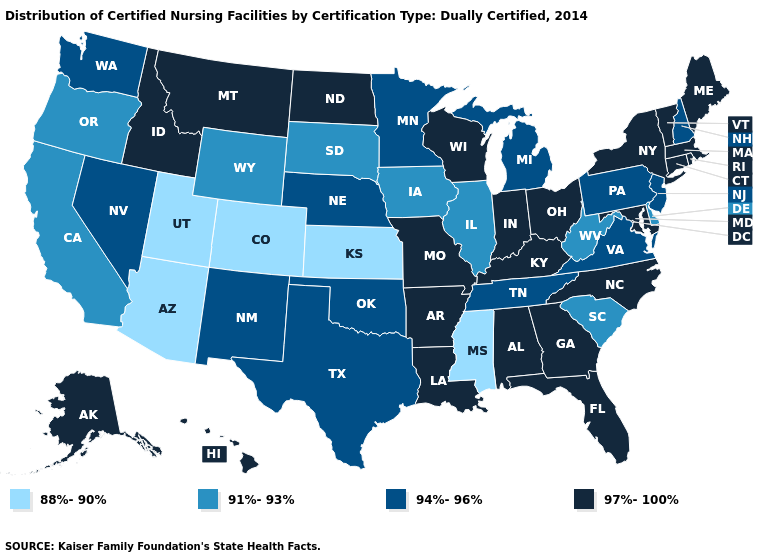Among the states that border New Mexico , which have the highest value?
Answer briefly. Oklahoma, Texas. Name the states that have a value in the range 94%-96%?
Be succinct. Michigan, Minnesota, Nebraska, Nevada, New Hampshire, New Jersey, New Mexico, Oklahoma, Pennsylvania, Tennessee, Texas, Virginia, Washington. Does Illinois have a lower value than South Dakota?
Write a very short answer. No. What is the highest value in the USA?
Be succinct. 97%-100%. Among the states that border Texas , which have the lowest value?
Answer briefly. New Mexico, Oklahoma. Does Louisiana have the highest value in the South?
Short answer required. Yes. Among the states that border Delaware , does Pennsylvania have the lowest value?
Concise answer only. Yes. Among the states that border Mississippi , which have the lowest value?
Write a very short answer. Tennessee. Does the first symbol in the legend represent the smallest category?
Be succinct. Yes. Does Maine have the lowest value in the Northeast?
Concise answer only. No. Name the states that have a value in the range 91%-93%?
Short answer required. California, Delaware, Illinois, Iowa, Oregon, South Carolina, South Dakota, West Virginia, Wyoming. Name the states that have a value in the range 94%-96%?
Short answer required. Michigan, Minnesota, Nebraska, Nevada, New Hampshire, New Jersey, New Mexico, Oklahoma, Pennsylvania, Tennessee, Texas, Virginia, Washington. Which states have the lowest value in the USA?
Write a very short answer. Arizona, Colorado, Kansas, Mississippi, Utah. What is the value of Hawaii?
Short answer required. 97%-100%. What is the value of Vermont?
Be succinct. 97%-100%. 